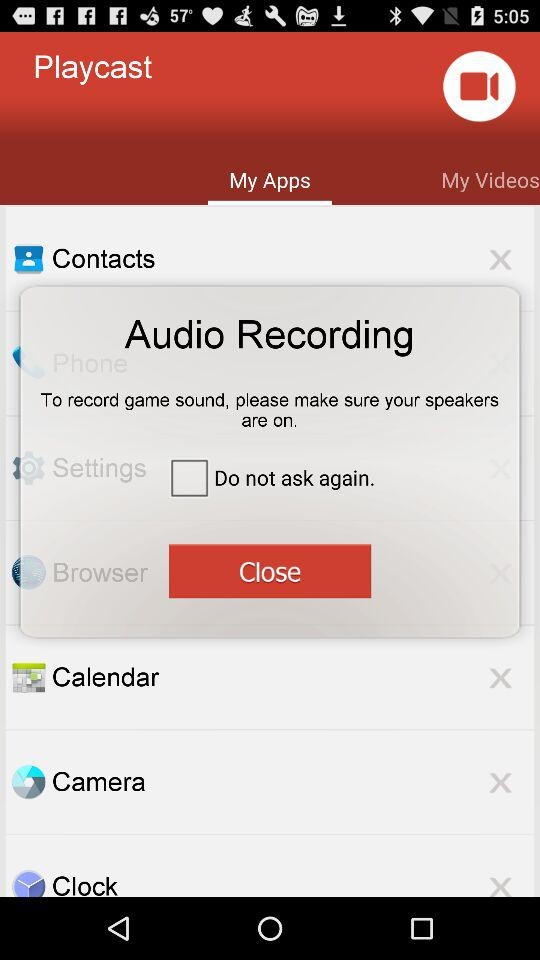What is the application name? The application name is "Playcast". 